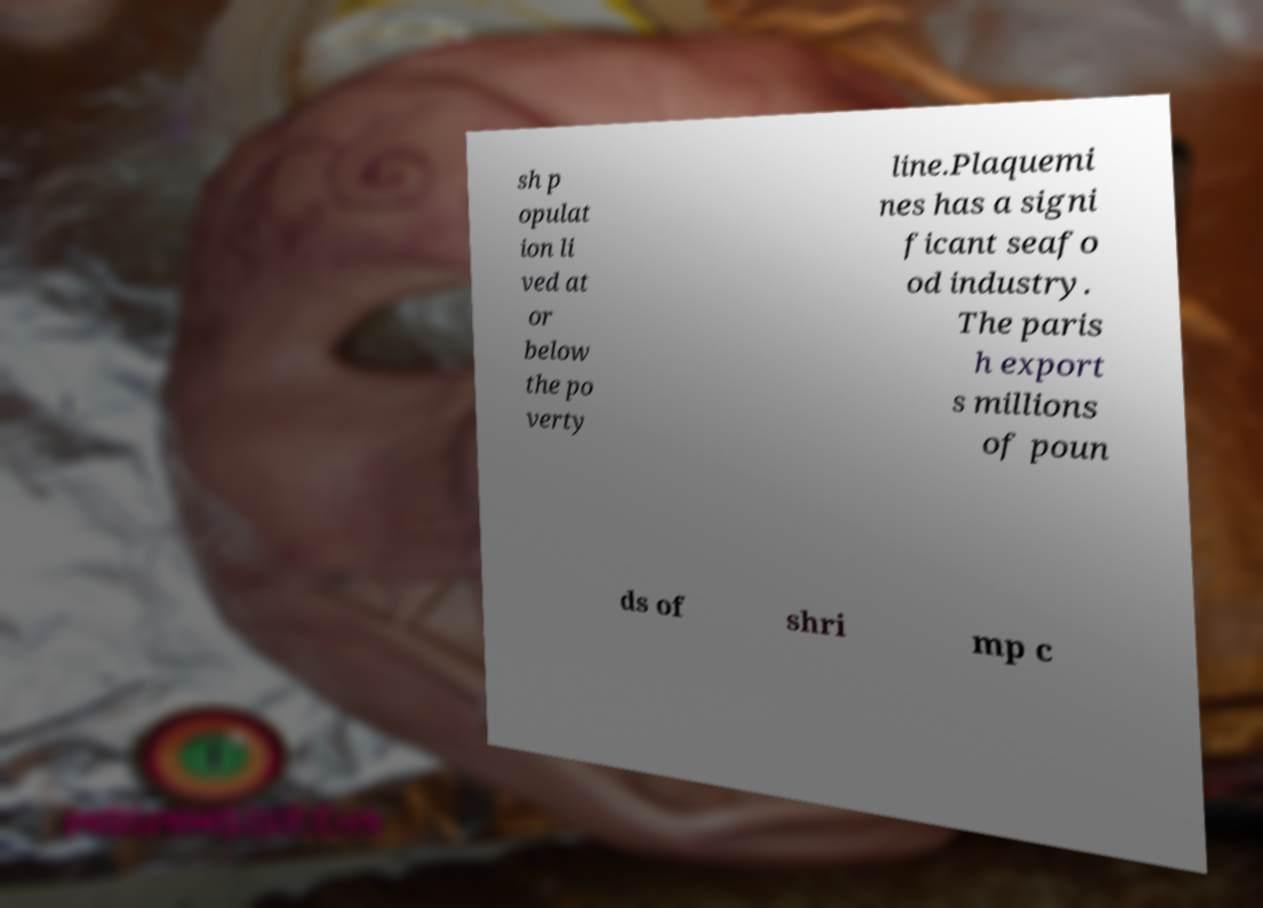Please identify and transcribe the text found in this image. sh p opulat ion li ved at or below the po verty line.Plaquemi nes has a signi ficant seafo od industry. The paris h export s millions of poun ds of shri mp c 